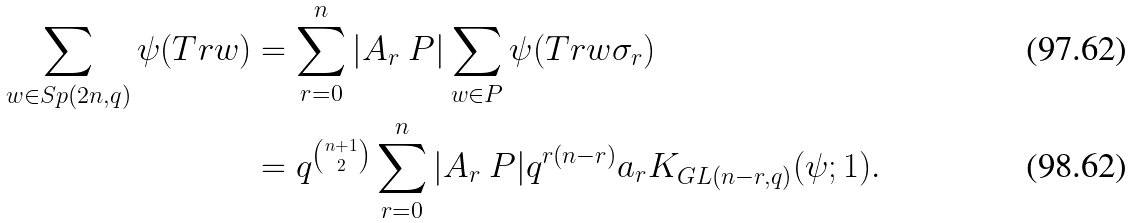<formula> <loc_0><loc_0><loc_500><loc_500>\sum _ { w \in S p ( 2 n , q ) } \psi ( T r w ) & = \sum _ { r = 0 } ^ { n } | A _ { r } \ P | \sum _ { w \in P } \psi ( T r w \sigma _ { r } ) \\ & = q ^ { n + 1 \choose 2 } \sum _ { r = 0 } ^ { n } | A _ { r } \ P | q ^ { r ( n - r ) } a _ { r } K _ { G L ( n - r , q ) } ( \psi ; 1 ) .</formula> 